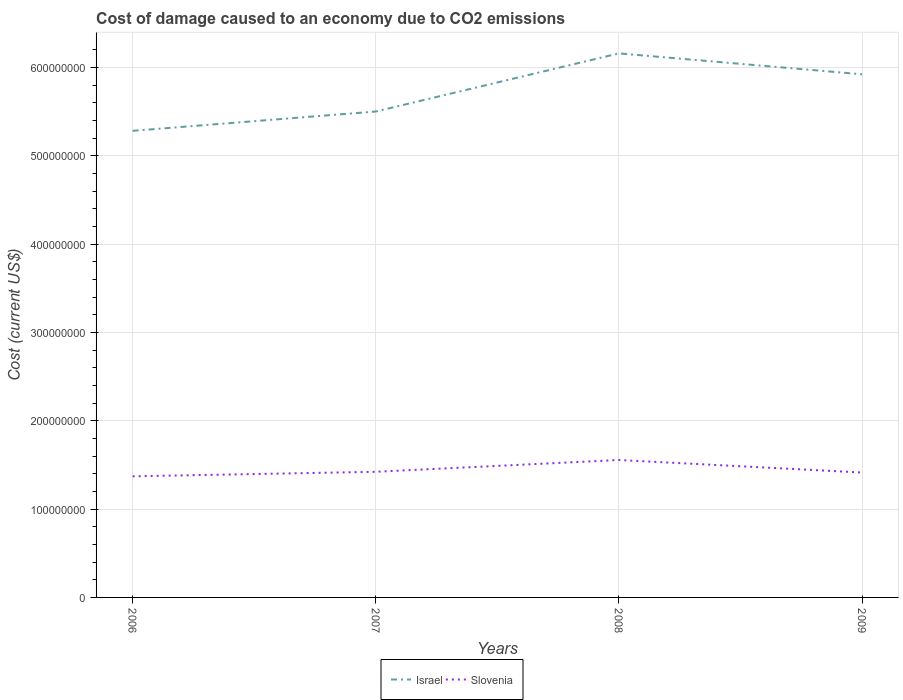How many different coloured lines are there?
Offer a terse response. 2. Is the number of lines equal to the number of legend labels?
Your answer should be compact. Yes. Across all years, what is the maximum cost of damage caused due to CO2 emissisons in Slovenia?
Your response must be concise. 1.37e+08. In which year was the cost of damage caused due to CO2 emissisons in Slovenia maximum?
Your answer should be compact. 2006. What is the total cost of damage caused due to CO2 emissisons in Israel in the graph?
Make the answer very short. -4.21e+07. What is the difference between the highest and the second highest cost of damage caused due to CO2 emissisons in Israel?
Your answer should be very brief. 8.77e+07. What is the difference between the highest and the lowest cost of damage caused due to CO2 emissisons in Israel?
Your answer should be very brief. 2. Is the cost of damage caused due to CO2 emissisons in Slovenia strictly greater than the cost of damage caused due to CO2 emissisons in Israel over the years?
Your response must be concise. Yes. How many lines are there?
Your answer should be compact. 2. What is the difference between two consecutive major ticks on the Y-axis?
Offer a very short reply. 1.00e+08. Are the values on the major ticks of Y-axis written in scientific E-notation?
Make the answer very short. No. How are the legend labels stacked?
Your answer should be very brief. Horizontal. What is the title of the graph?
Make the answer very short. Cost of damage caused to an economy due to CO2 emissions. Does "Algeria" appear as one of the legend labels in the graph?
Make the answer very short. No. What is the label or title of the X-axis?
Offer a terse response. Years. What is the label or title of the Y-axis?
Provide a succinct answer. Cost (current US$). What is the Cost (current US$) of Israel in 2006?
Offer a terse response. 5.28e+08. What is the Cost (current US$) in Slovenia in 2006?
Offer a very short reply. 1.37e+08. What is the Cost (current US$) of Israel in 2007?
Keep it short and to the point. 5.50e+08. What is the Cost (current US$) in Slovenia in 2007?
Provide a short and direct response. 1.42e+08. What is the Cost (current US$) of Israel in 2008?
Your answer should be compact. 6.16e+08. What is the Cost (current US$) in Slovenia in 2008?
Your response must be concise. 1.56e+08. What is the Cost (current US$) of Israel in 2009?
Provide a succinct answer. 5.92e+08. What is the Cost (current US$) in Slovenia in 2009?
Your answer should be very brief. 1.41e+08. Across all years, what is the maximum Cost (current US$) in Israel?
Keep it short and to the point. 6.16e+08. Across all years, what is the maximum Cost (current US$) of Slovenia?
Your answer should be compact. 1.56e+08. Across all years, what is the minimum Cost (current US$) in Israel?
Your answer should be compact. 5.28e+08. Across all years, what is the minimum Cost (current US$) of Slovenia?
Your response must be concise. 1.37e+08. What is the total Cost (current US$) in Israel in the graph?
Offer a very short reply. 2.29e+09. What is the total Cost (current US$) of Slovenia in the graph?
Make the answer very short. 5.76e+08. What is the difference between the Cost (current US$) of Israel in 2006 and that in 2007?
Offer a very short reply. -2.19e+07. What is the difference between the Cost (current US$) in Slovenia in 2006 and that in 2007?
Give a very brief answer. -5.13e+06. What is the difference between the Cost (current US$) of Israel in 2006 and that in 2008?
Offer a very short reply. -8.77e+07. What is the difference between the Cost (current US$) in Slovenia in 2006 and that in 2008?
Give a very brief answer. -1.85e+07. What is the difference between the Cost (current US$) in Israel in 2006 and that in 2009?
Your response must be concise. -6.40e+07. What is the difference between the Cost (current US$) of Slovenia in 2006 and that in 2009?
Make the answer very short. -4.30e+06. What is the difference between the Cost (current US$) in Israel in 2007 and that in 2008?
Give a very brief answer. -6.58e+07. What is the difference between the Cost (current US$) in Slovenia in 2007 and that in 2008?
Make the answer very short. -1.34e+07. What is the difference between the Cost (current US$) of Israel in 2007 and that in 2009?
Provide a short and direct response. -4.21e+07. What is the difference between the Cost (current US$) in Slovenia in 2007 and that in 2009?
Ensure brevity in your answer.  8.34e+05. What is the difference between the Cost (current US$) in Israel in 2008 and that in 2009?
Your response must be concise. 2.37e+07. What is the difference between the Cost (current US$) of Slovenia in 2008 and that in 2009?
Give a very brief answer. 1.42e+07. What is the difference between the Cost (current US$) of Israel in 2006 and the Cost (current US$) of Slovenia in 2007?
Your answer should be compact. 3.86e+08. What is the difference between the Cost (current US$) in Israel in 2006 and the Cost (current US$) in Slovenia in 2008?
Your response must be concise. 3.73e+08. What is the difference between the Cost (current US$) in Israel in 2006 and the Cost (current US$) in Slovenia in 2009?
Offer a very short reply. 3.87e+08. What is the difference between the Cost (current US$) of Israel in 2007 and the Cost (current US$) of Slovenia in 2008?
Your answer should be compact. 3.95e+08. What is the difference between the Cost (current US$) in Israel in 2007 and the Cost (current US$) in Slovenia in 2009?
Ensure brevity in your answer.  4.09e+08. What is the difference between the Cost (current US$) in Israel in 2008 and the Cost (current US$) in Slovenia in 2009?
Make the answer very short. 4.75e+08. What is the average Cost (current US$) of Israel per year?
Provide a short and direct response. 5.72e+08. What is the average Cost (current US$) in Slovenia per year?
Give a very brief answer. 1.44e+08. In the year 2006, what is the difference between the Cost (current US$) of Israel and Cost (current US$) of Slovenia?
Provide a short and direct response. 3.91e+08. In the year 2007, what is the difference between the Cost (current US$) of Israel and Cost (current US$) of Slovenia?
Offer a terse response. 4.08e+08. In the year 2008, what is the difference between the Cost (current US$) in Israel and Cost (current US$) in Slovenia?
Make the answer very short. 4.60e+08. In the year 2009, what is the difference between the Cost (current US$) in Israel and Cost (current US$) in Slovenia?
Provide a short and direct response. 4.51e+08. What is the ratio of the Cost (current US$) in Israel in 2006 to that in 2007?
Your answer should be compact. 0.96. What is the ratio of the Cost (current US$) of Slovenia in 2006 to that in 2007?
Offer a very short reply. 0.96. What is the ratio of the Cost (current US$) in Israel in 2006 to that in 2008?
Give a very brief answer. 0.86. What is the ratio of the Cost (current US$) of Slovenia in 2006 to that in 2008?
Give a very brief answer. 0.88. What is the ratio of the Cost (current US$) of Israel in 2006 to that in 2009?
Give a very brief answer. 0.89. What is the ratio of the Cost (current US$) of Slovenia in 2006 to that in 2009?
Ensure brevity in your answer.  0.97. What is the ratio of the Cost (current US$) in Israel in 2007 to that in 2008?
Give a very brief answer. 0.89. What is the ratio of the Cost (current US$) in Slovenia in 2007 to that in 2008?
Keep it short and to the point. 0.91. What is the ratio of the Cost (current US$) of Israel in 2007 to that in 2009?
Keep it short and to the point. 0.93. What is the ratio of the Cost (current US$) of Slovenia in 2007 to that in 2009?
Keep it short and to the point. 1.01. What is the ratio of the Cost (current US$) of Slovenia in 2008 to that in 2009?
Make the answer very short. 1.1. What is the difference between the highest and the second highest Cost (current US$) of Israel?
Provide a short and direct response. 2.37e+07. What is the difference between the highest and the second highest Cost (current US$) in Slovenia?
Ensure brevity in your answer.  1.34e+07. What is the difference between the highest and the lowest Cost (current US$) in Israel?
Make the answer very short. 8.77e+07. What is the difference between the highest and the lowest Cost (current US$) in Slovenia?
Give a very brief answer. 1.85e+07. 